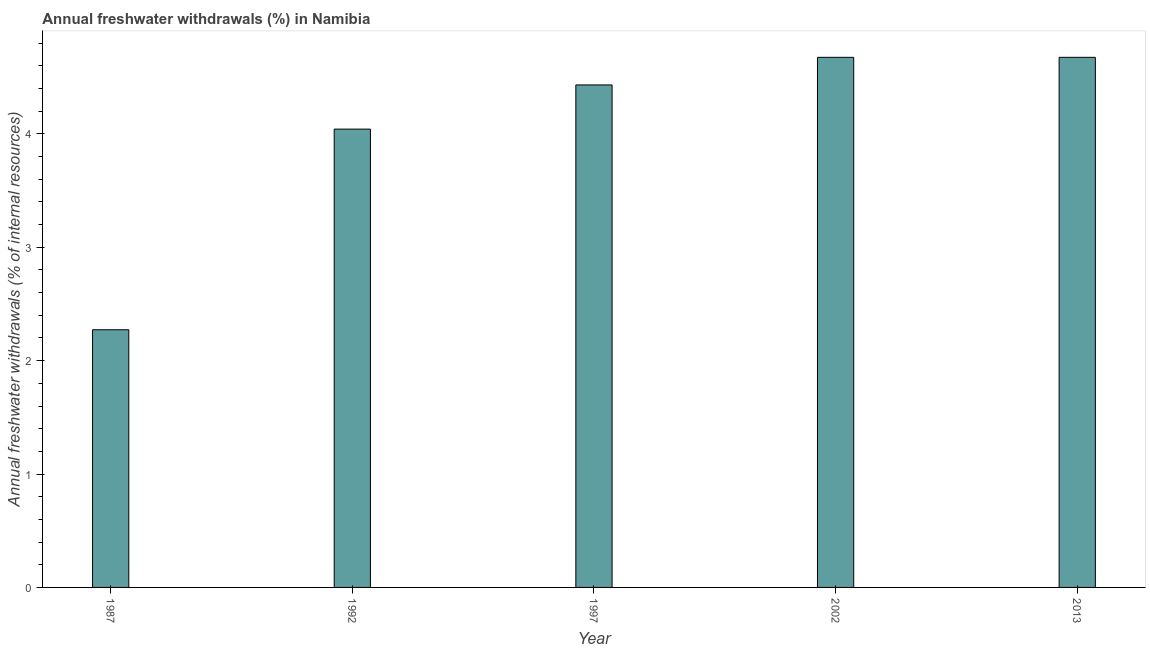What is the title of the graph?
Ensure brevity in your answer.  Annual freshwater withdrawals (%) in Namibia. What is the label or title of the Y-axis?
Your answer should be very brief. Annual freshwater withdrawals (% of internal resources). What is the annual freshwater withdrawals in 2002?
Your response must be concise. 4.68. Across all years, what is the maximum annual freshwater withdrawals?
Offer a very short reply. 4.68. Across all years, what is the minimum annual freshwater withdrawals?
Offer a very short reply. 2.27. What is the sum of the annual freshwater withdrawals?
Ensure brevity in your answer.  20.1. What is the difference between the annual freshwater withdrawals in 1997 and 2002?
Keep it short and to the point. -0.24. What is the average annual freshwater withdrawals per year?
Your answer should be very brief. 4.02. What is the median annual freshwater withdrawals?
Your answer should be compact. 4.43. In how many years, is the annual freshwater withdrawals greater than 3.6 %?
Provide a short and direct response. 4. Do a majority of the years between 1992 and 2013 (inclusive) have annual freshwater withdrawals greater than 3.4 %?
Your answer should be compact. Yes. What is the ratio of the annual freshwater withdrawals in 1992 to that in 2013?
Your response must be concise. 0.86. Is the annual freshwater withdrawals in 1987 less than that in 1992?
Ensure brevity in your answer.  Yes. Is the difference between the annual freshwater withdrawals in 1987 and 2013 greater than the difference between any two years?
Your response must be concise. Yes. What is the difference between the highest and the second highest annual freshwater withdrawals?
Make the answer very short. 0. Is the sum of the annual freshwater withdrawals in 1987 and 2013 greater than the maximum annual freshwater withdrawals across all years?
Provide a succinct answer. Yes. In how many years, is the annual freshwater withdrawals greater than the average annual freshwater withdrawals taken over all years?
Make the answer very short. 4. How many bars are there?
Provide a succinct answer. 5. Are all the bars in the graph horizontal?
Offer a very short reply. No. Are the values on the major ticks of Y-axis written in scientific E-notation?
Make the answer very short. No. What is the Annual freshwater withdrawals (% of internal resources) in 1987?
Your answer should be very brief. 2.27. What is the Annual freshwater withdrawals (% of internal resources) of 1992?
Your answer should be compact. 4.04. What is the Annual freshwater withdrawals (% of internal resources) of 1997?
Give a very brief answer. 4.43. What is the Annual freshwater withdrawals (% of internal resources) of 2002?
Make the answer very short. 4.68. What is the Annual freshwater withdrawals (% of internal resources) in 2013?
Give a very brief answer. 4.68. What is the difference between the Annual freshwater withdrawals (% of internal resources) in 1987 and 1992?
Ensure brevity in your answer.  -1.77. What is the difference between the Annual freshwater withdrawals (% of internal resources) in 1987 and 1997?
Ensure brevity in your answer.  -2.16. What is the difference between the Annual freshwater withdrawals (% of internal resources) in 1987 and 2002?
Make the answer very short. -2.4. What is the difference between the Annual freshwater withdrawals (% of internal resources) in 1987 and 2013?
Provide a succinct answer. -2.4. What is the difference between the Annual freshwater withdrawals (% of internal resources) in 1992 and 1997?
Keep it short and to the point. -0.39. What is the difference between the Annual freshwater withdrawals (% of internal resources) in 1992 and 2002?
Your answer should be compact. -0.63. What is the difference between the Annual freshwater withdrawals (% of internal resources) in 1992 and 2013?
Keep it short and to the point. -0.63. What is the difference between the Annual freshwater withdrawals (% of internal resources) in 1997 and 2002?
Make the answer very short. -0.24. What is the difference between the Annual freshwater withdrawals (% of internal resources) in 1997 and 2013?
Offer a terse response. -0.24. What is the ratio of the Annual freshwater withdrawals (% of internal resources) in 1987 to that in 1992?
Ensure brevity in your answer.  0.56. What is the ratio of the Annual freshwater withdrawals (% of internal resources) in 1987 to that in 1997?
Your answer should be compact. 0.51. What is the ratio of the Annual freshwater withdrawals (% of internal resources) in 1987 to that in 2002?
Provide a succinct answer. 0.49. What is the ratio of the Annual freshwater withdrawals (% of internal resources) in 1987 to that in 2013?
Offer a very short reply. 0.49. What is the ratio of the Annual freshwater withdrawals (% of internal resources) in 1992 to that in 1997?
Your answer should be compact. 0.91. What is the ratio of the Annual freshwater withdrawals (% of internal resources) in 1992 to that in 2002?
Give a very brief answer. 0.86. What is the ratio of the Annual freshwater withdrawals (% of internal resources) in 1992 to that in 2013?
Your answer should be compact. 0.86. What is the ratio of the Annual freshwater withdrawals (% of internal resources) in 1997 to that in 2002?
Your response must be concise. 0.95. What is the ratio of the Annual freshwater withdrawals (% of internal resources) in 1997 to that in 2013?
Keep it short and to the point. 0.95. What is the ratio of the Annual freshwater withdrawals (% of internal resources) in 2002 to that in 2013?
Offer a terse response. 1. 